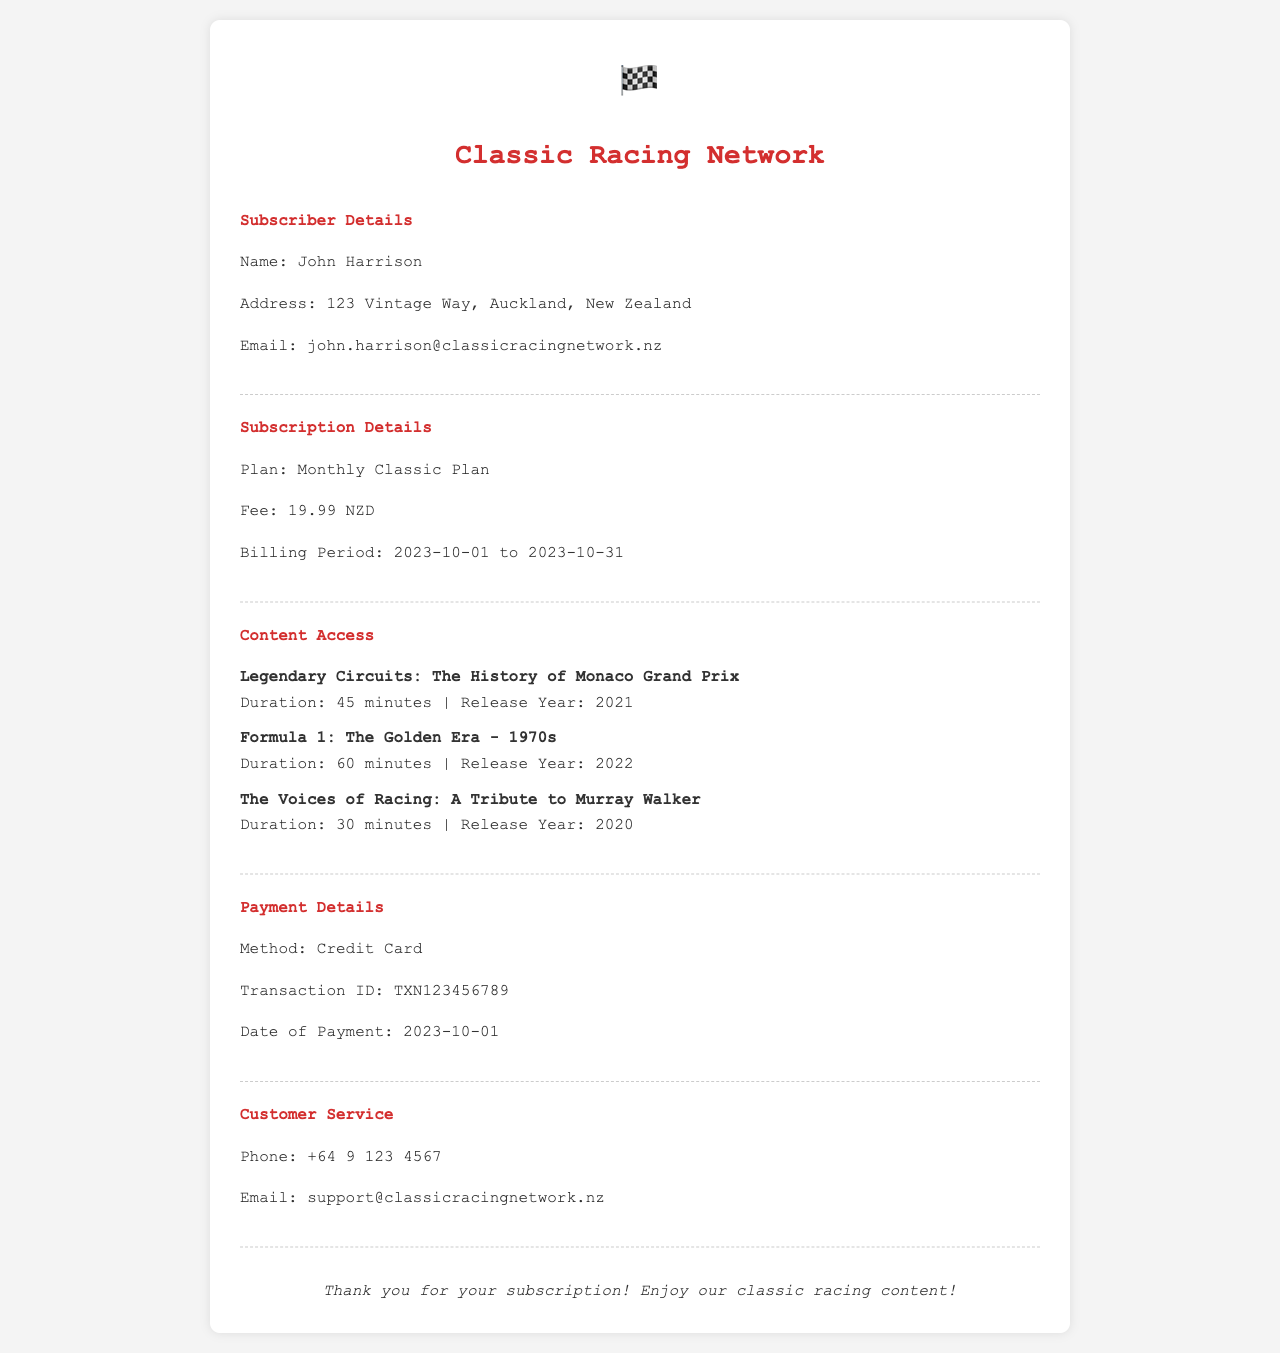What is the subscriber's name? The subscriber's name is clearly stated in the document under Subscriber Details.
Answer: John Harrison What is the subscription fee? The fee for the Monthly Classic Plan is specified in the Subscription Details section.
Answer: 19.99 NZD What is the billing period? The billing period is indicated in the Subscription Details section, showing the range of dates.
Answer: 2023-10-01 to 2023-10-31 How many documentaries are listed under Content Access? The number of documentaries is counted in the Content Access section.
Answer: 3 What is the transaction ID? The transaction ID is mentioned in the Payment Details section.
Answer: TXN123456789 Which plan is the subscriber on? The plan type is stated in the Subscription Details section.
Answer: Monthly Classic Plan What payment method was used? The payment method is specified in the Payment Details section of the document.
Answer: Credit Card What is the duration of "Legendary Circuits: The History of Monaco Grand Prix"? The duration is mentioned alongside the title in the Content Access section.
Answer: 45 minutes Who can be contacted for customer service? Customer service contact information is provided in the Customer Service section.
Answer: support@classicracingnetwork.nz 